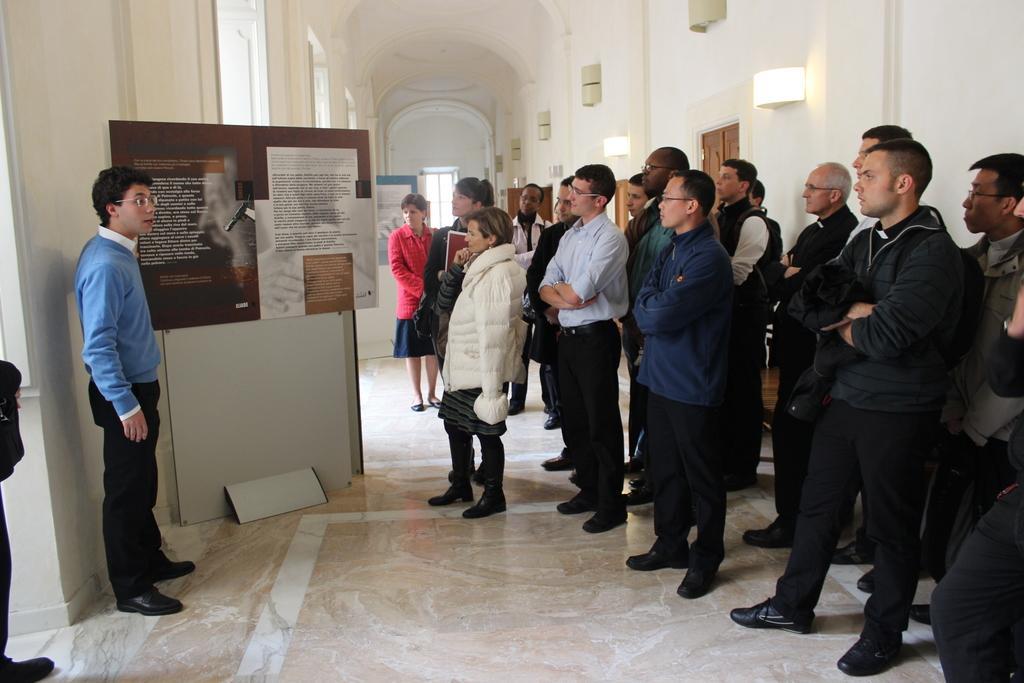Could you give a brief overview of what you see in this image? In this picture, we see many people are standing and listening to the man on the opposite side. The man on the left side of the picture wearing a blue jacket and spectacles is explaining something. Beside him, we see a brown board with some text written on it. In the background, we see a white wall and a window. This picture is clicked inside the building. 